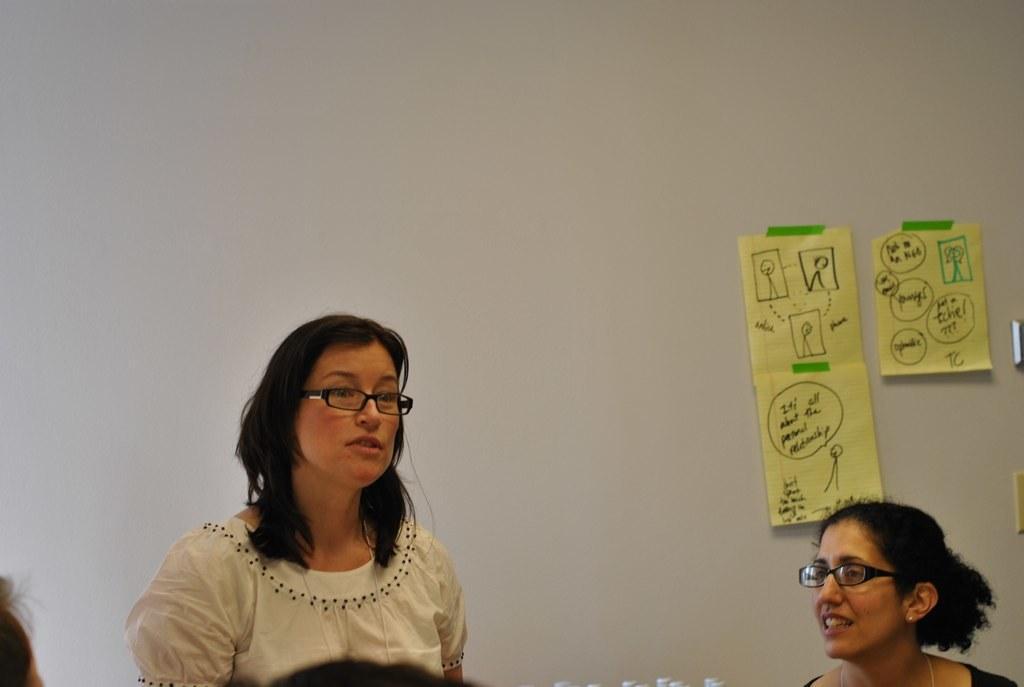Describe this image in one or two sentences. This picture is clicked inside. In the foreground we can see the group of persons. On the right we can see the posters hanging on the wall and we can see the text and some drawing on the posters. 